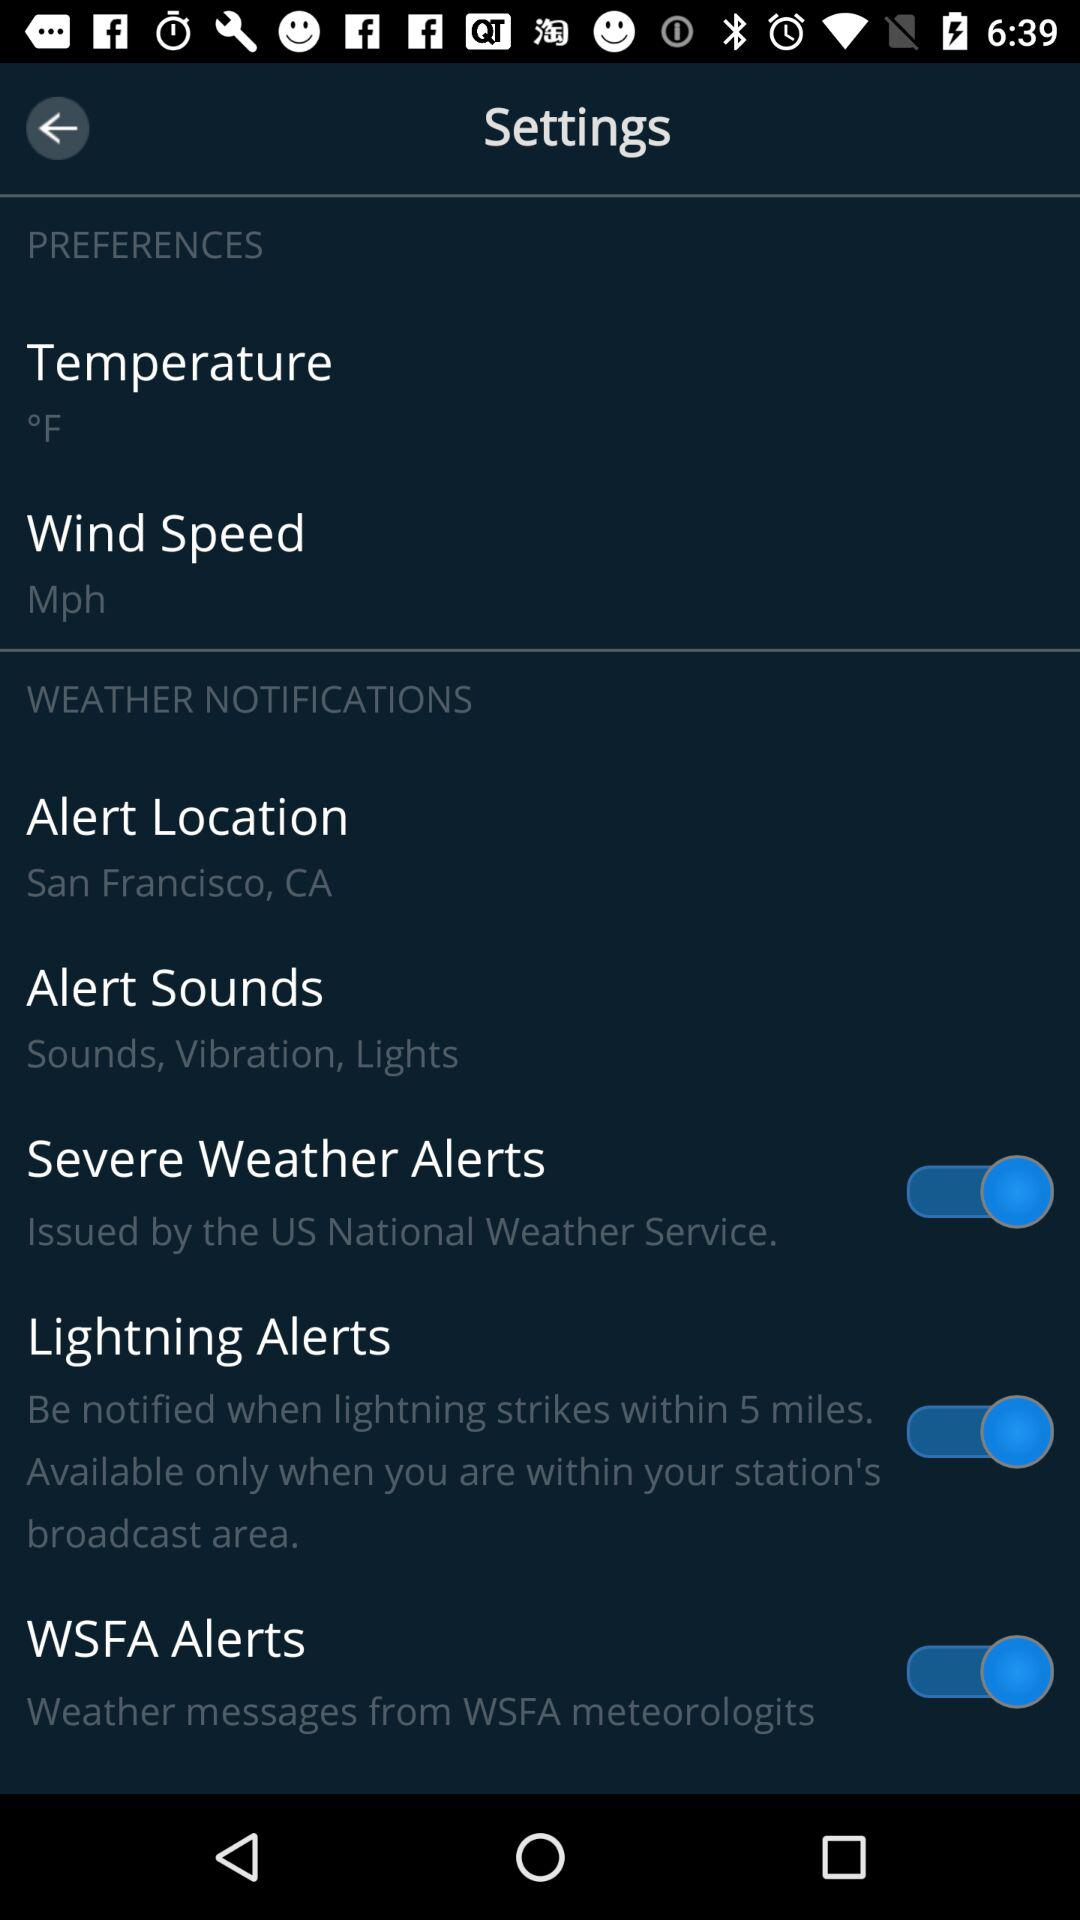What is the status of "Lightning Alerts"? The status is "on". 